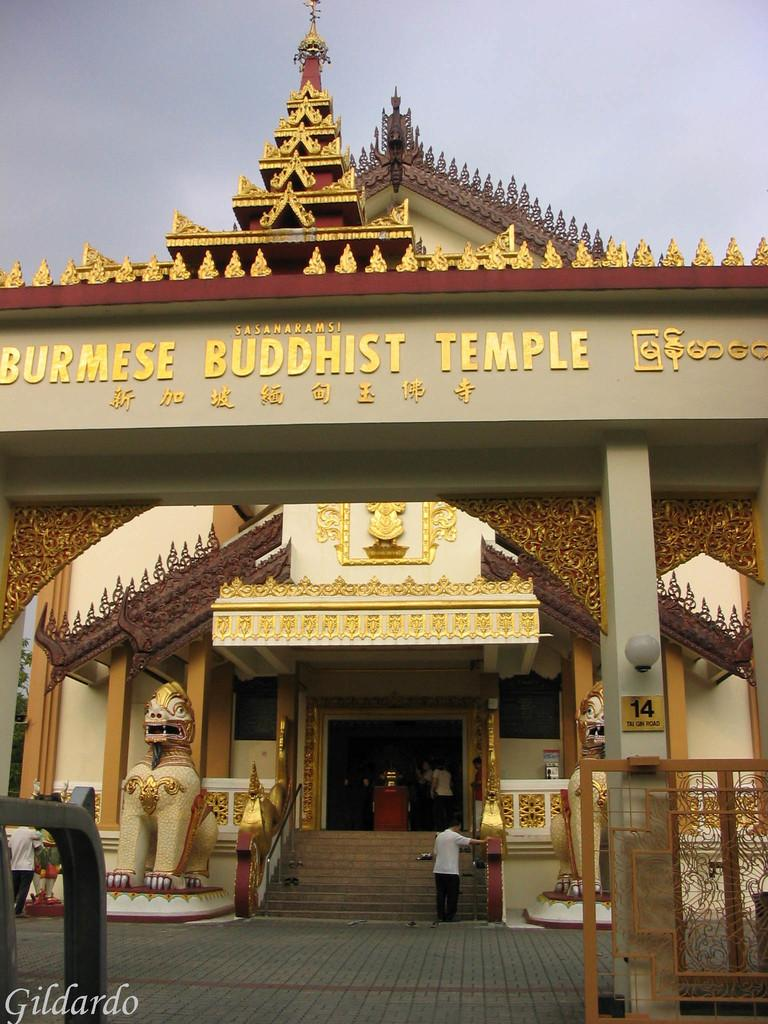What type of structure is depicted in the image? There is a temple in the image. Can you describe a specific part of the temple? There is an arc of a temple in the image. Are there any people present in the image? Yes, there are people standing in the image. What else can be seen in the image besides the temple and people? Sculptures and other objects are present in the image. What can be seen in the background of the image? The sky is visible in the background of the image. What type of jar is being blown by the people in the image? There is no jar present in the image, nor are people blowing anything. What feeling is being expressed by the sculptures in the image? The image does not convey any specific feelings or emotions through the sculptures; they are simply depicted as part of the scene. 